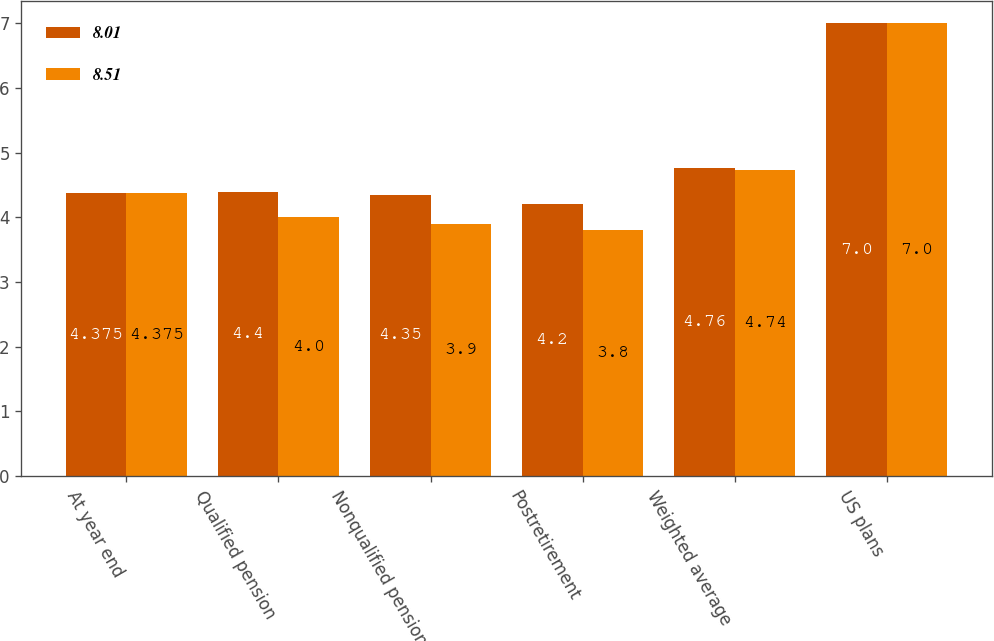Convert chart. <chart><loc_0><loc_0><loc_500><loc_500><stacked_bar_chart><ecel><fcel>At year end<fcel>Qualified pension<fcel>Nonqualified pension<fcel>Postretirement<fcel>Weighted average<fcel>US plans<nl><fcel>8.01<fcel>4.375<fcel>4.4<fcel>4.35<fcel>4.2<fcel>4.76<fcel>7<nl><fcel>8.51<fcel>4.375<fcel>4<fcel>3.9<fcel>3.8<fcel>4.74<fcel>7<nl></chart> 